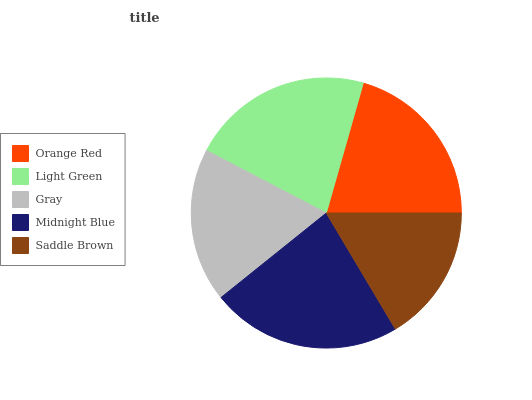Is Saddle Brown the minimum?
Answer yes or no. Yes. Is Midnight Blue the maximum?
Answer yes or no. Yes. Is Light Green the minimum?
Answer yes or no. No. Is Light Green the maximum?
Answer yes or no. No. Is Light Green greater than Orange Red?
Answer yes or no. Yes. Is Orange Red less than Light Green?
Answer yes or no. Yes. Is Orange Red greater than Light Green?
Answer yes or no. No. Is Light Green less than Orange Red?
Answer yes or no. No. Is Orange Red the high median?
Answer yes or no. Yes. Is Orange Red the low median?
Answer yes or no. Yes. Is Midnight Blue the high median?
Answer yes or no. No. Is Gray the low median?
Answer yes or no. No. 